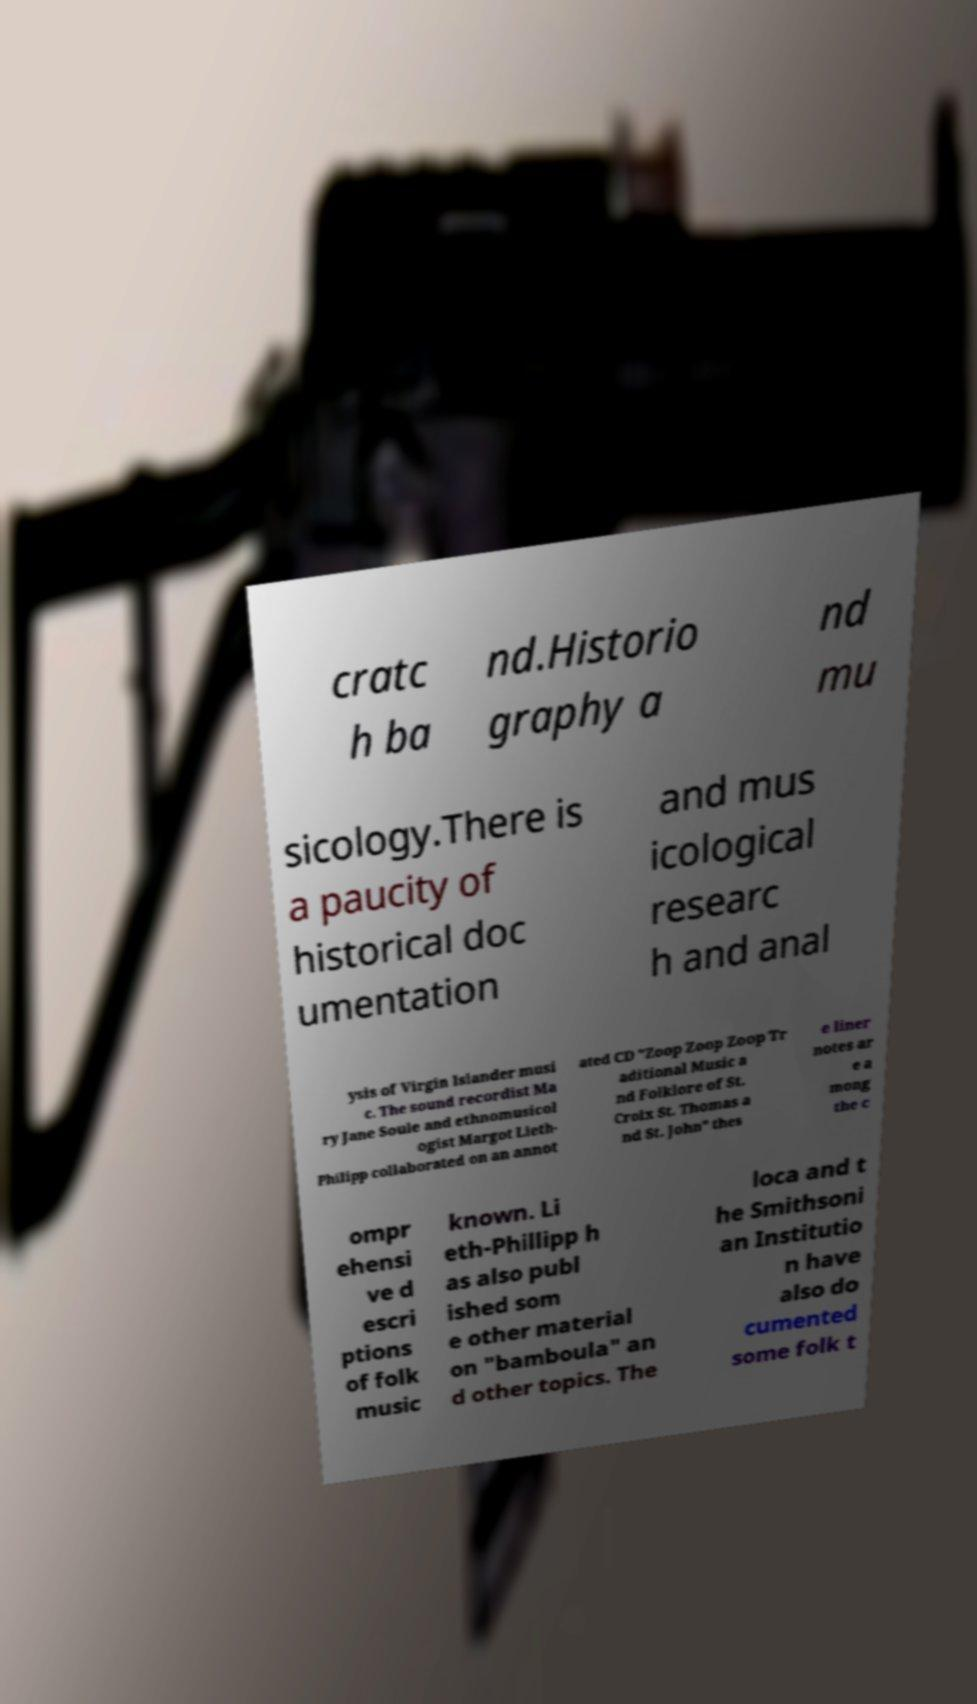For documentation purposes, I need the text within this image transcribed. Could you provide that? cratc h ba nd.Historio graphy a nd mu sicology.There is a paucity of historical doc umentation and mus icological researc h and anal ysis of Virgin Islander musi c. The sound recordist Ma ry Jane Soule and ethnomusicol ogist Margot Lieth- Philipp collaborated on an annot ated CD "Zoop Zoop Zoop Tr aditional Music a nd Folklore of St. Croix St. Thomas a nd St. John" thes e liner notes ar e a mong the c ompr ehensi ve d escri ptions of folk music known. Li eth-Phillipp h as also publ ished som e other material on "bamboula" an d other topics. The loca and t he Smithsoni an Institutio n have also do cumented some folk t 